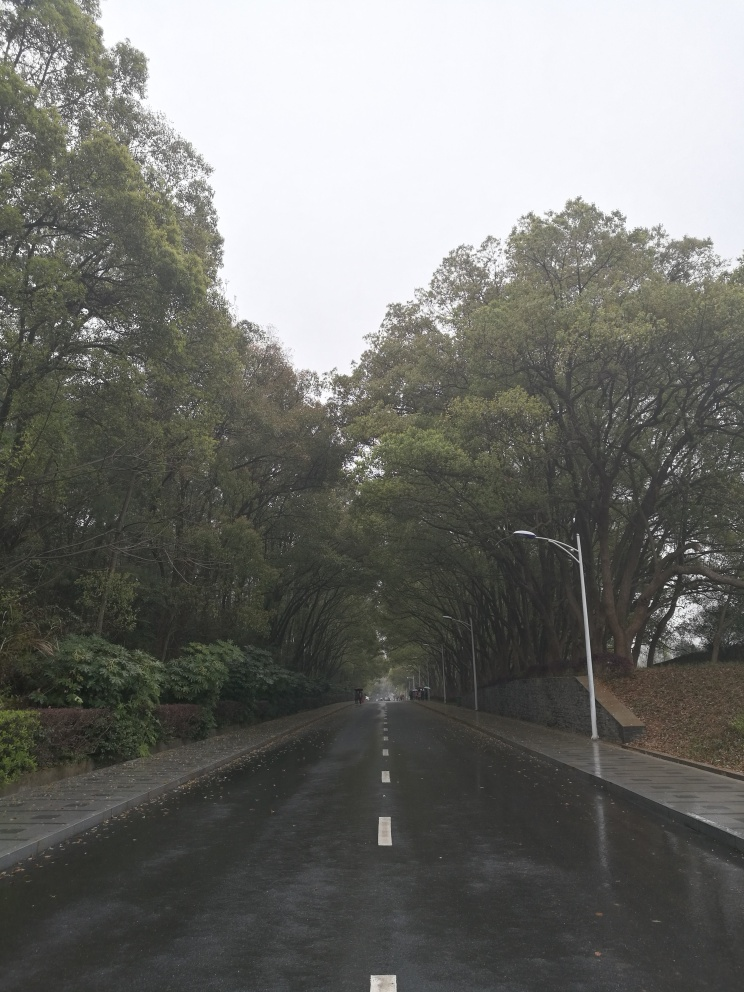Is the overall quality of this photo below average? Upon reviewing the image, it appears that the quality is not below average. Despite the overcast sky which results in subdued lighting conditions, the photo has clear focus and captures the moody ambiance of the scene. The road is well-defined with a calm and serene atmosphere, evoking a certain peacefulness that is conveyed effectively through the image quality. 